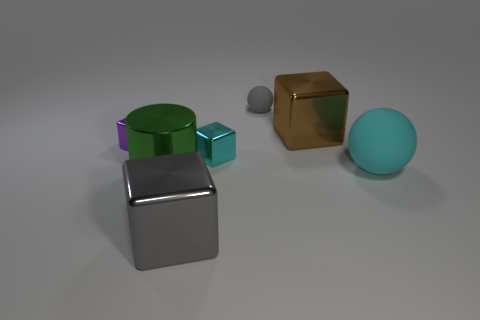Are the large gray block and the block that is on the left side of the large metallic cylinder made of the same material?
Ensure brevity in your answer.  Yes. There is a small cube on the right side of the gray thing in front of the large matte ball; what number of large green metal cylinders are behind it?
Ensure brevity in your answer.  0. How many blue things are small rubber things or small shiny things?
Offer a very short reply. 0. What is the shape of the gray thing behind the brown shiny block?
Offer a very short reply. Sphere. There is a ball that is the same size as the cylinder; what is its color?
Provide a succinct answer. Cyan. Is the shape of the purple metal object the same as the gray object that is behind the big brown block?
Keep it short and to the point. No. What is the material of the block that is to the right of the gray thing behind the large thing that is behind the large matte object?
Keep it short and to the point. Metal. How many small objects are either yellow cylinders or cubes?
Provide a short and direct response. 2. How many other objects are there of the same size as the purple object?
Give a very brief answer. 2. There is a big metal thing right of the gray shiny object; is its shape the same as the cyan rubber thing?
Your answer should be compact. No. 